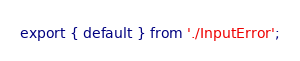Convert code to text. <code><loc_0><loc_0><loc_500><loc_500><_TypeScript_>export { default } from './InputError';
</code> 